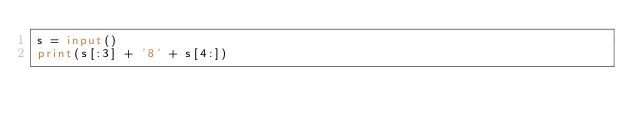<code> <loc_0><loc_0><loc_500><loc_500><_Python_>s = input()
print(s[:3] + '8' + s[4:])</code> 